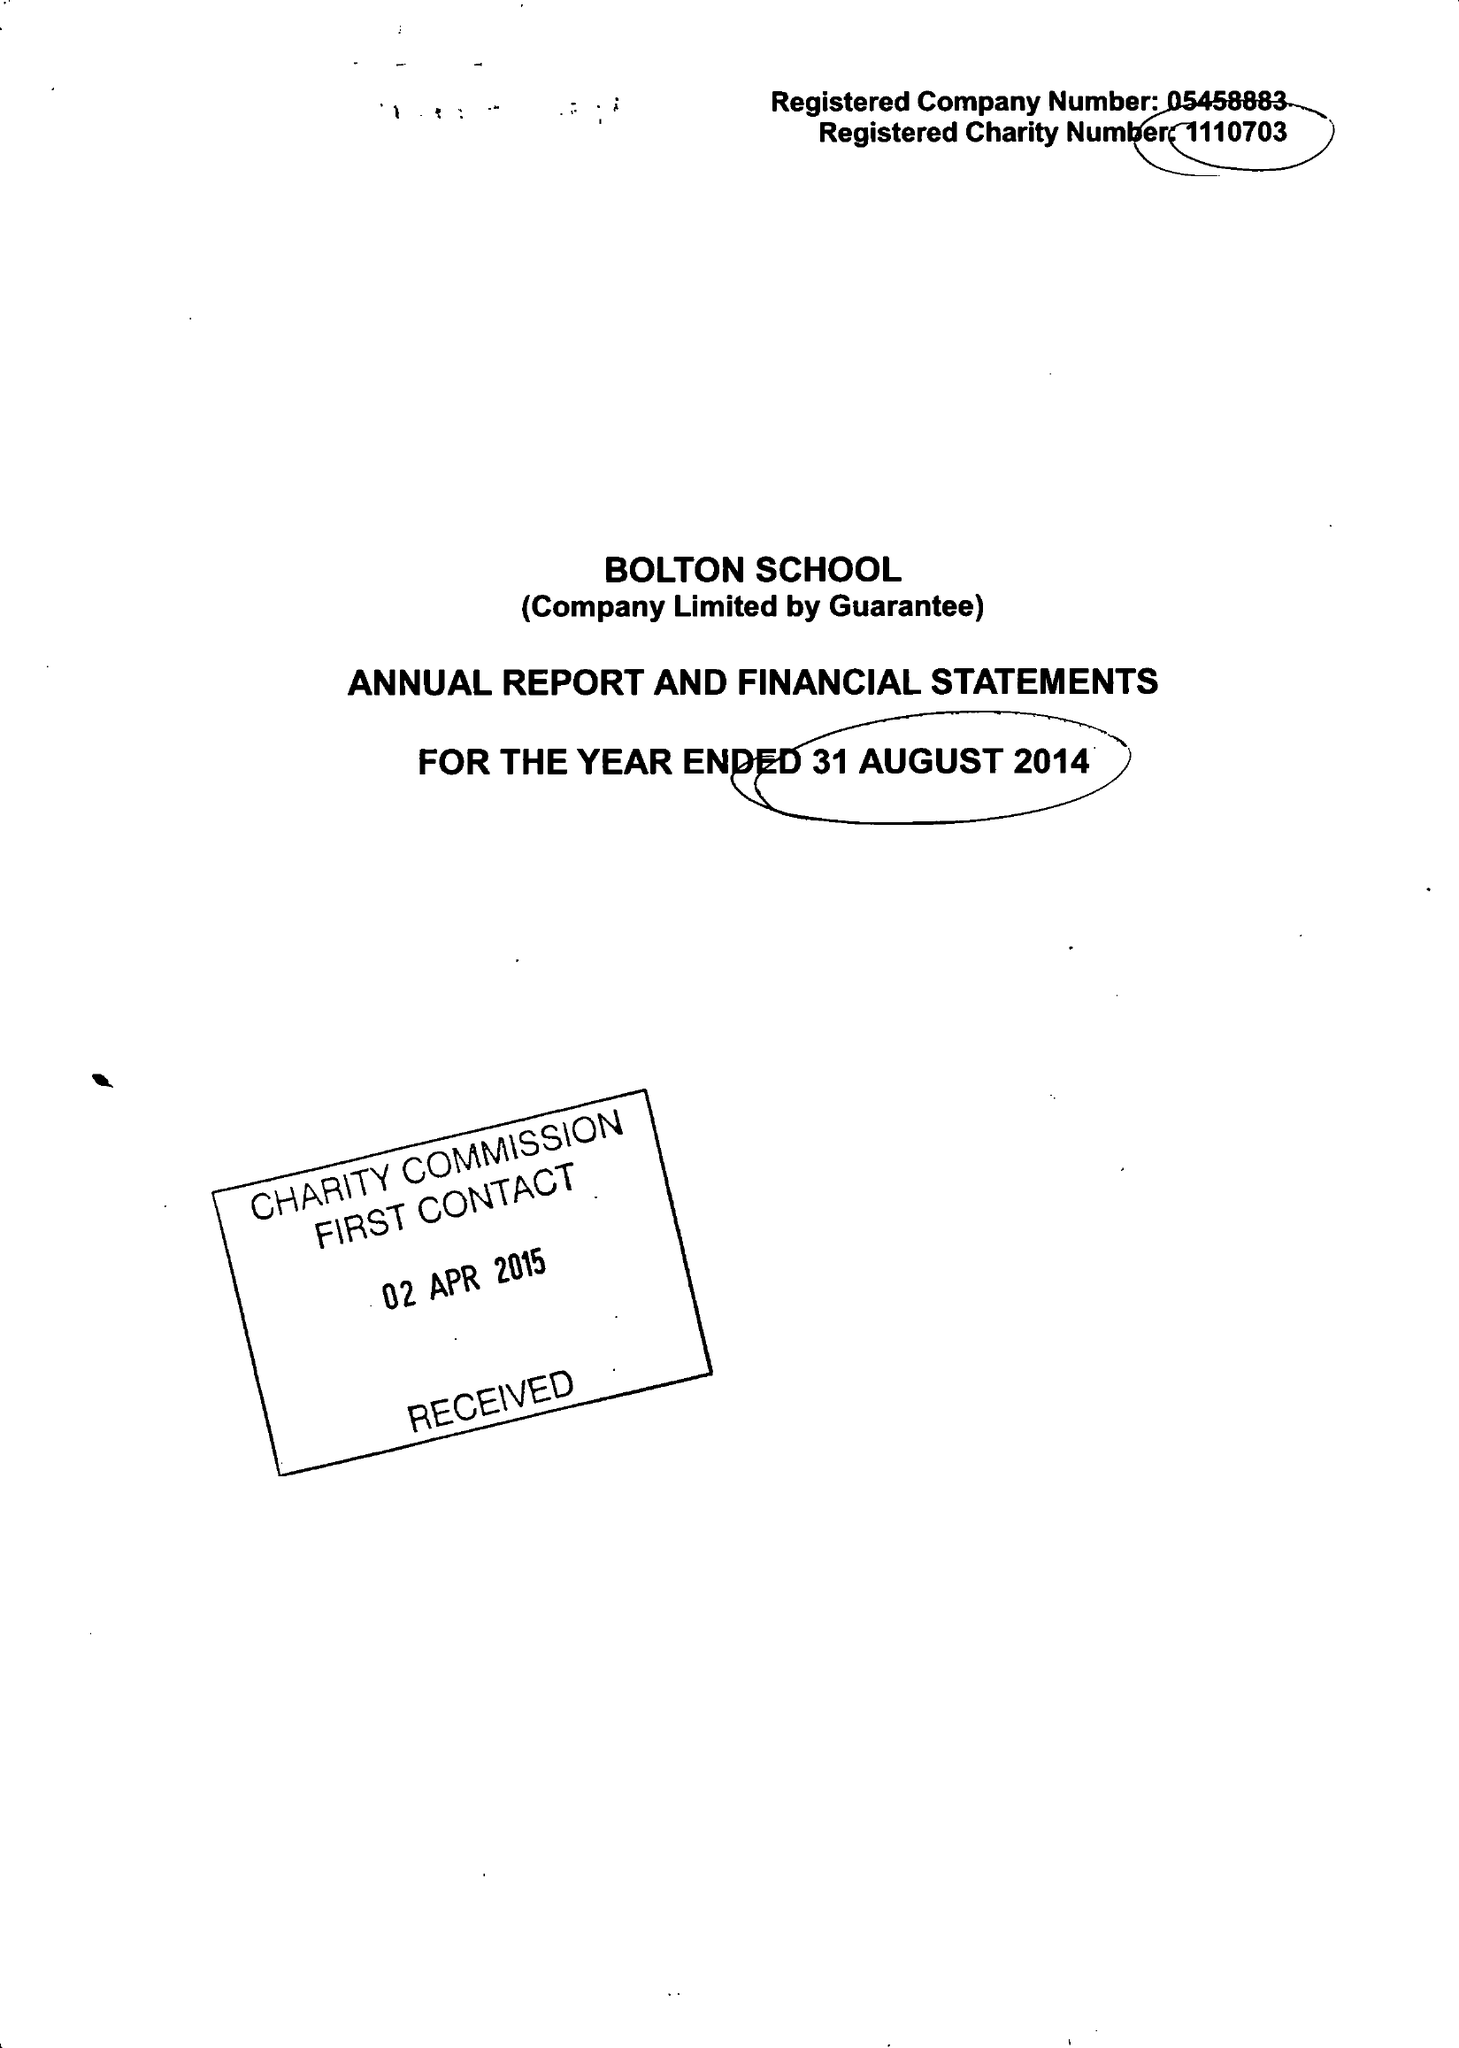What is the value for the address__postcode?
Answer the question using a single word or phrase. BL1 4PA 